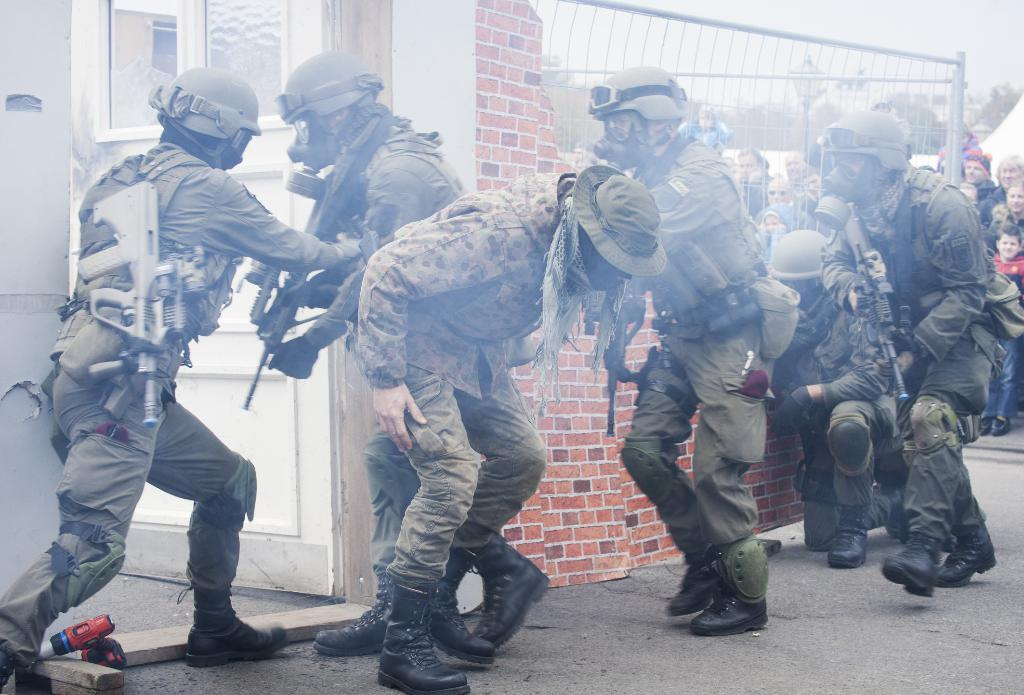How many people are present in the image? There are persons in the image, but the exact number is not specified. What is one architectural feature visible in the image? There is a door in the image. What type of structure can be seen in the image? There is a wall in the image. What can be seen in the background of the image? In the background of the image, there is a fence, poles, a light, trees, a group of people, and the sky. What type of fruit is hanging from the side of the door in the image? There is no fruit hanging from the door or any other part of the image. 